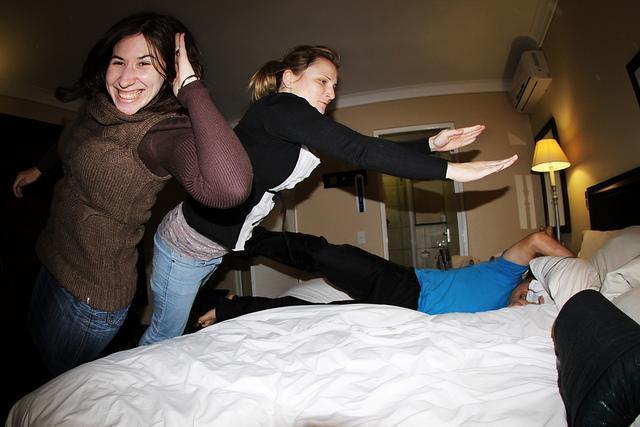It is time to hit the?
Make your selection from the four choices given to correctly answer the question.
Options: Bed, waves, hay, weights. Hay. Where are these people?
Indicate the correct response and explain using: 'Answer: answer
Rationale: rationale.'
Options: Car dealership, spa, hotel room, outside. Answer: hotel room.
Rationale: The room is in a hotel. 